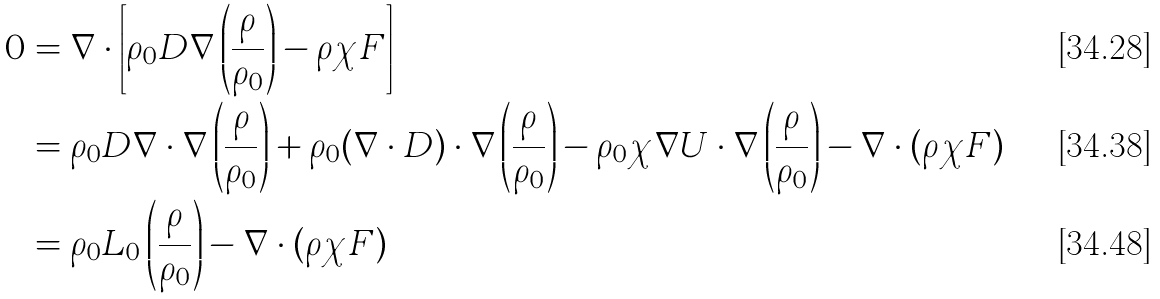Convert formula to latex. <formula><loc_0><loc_0><loc_500><loc_500>0 & = \nabla \cdot \left [ \rho _ { 0 } D \nabla \left ( \frac { \rho } { \rho _ { 0 } } \right ) - \rho \chi F \right ] \\ & = \rho _ { 0 } D \nabla \cdot \nabla \left ( \frac { \rho } { \rho _ { 0 } } \right ) + \rho _ { 0 } ( \nabla \cdot D ) \cdot \nabla \left ( \frac { \rho } { \rho _ { 0 } } \right ) - \rho _ { 0 } \chi \nabla U \cdot \nabla \left ( \frac { \rho } { \rho _ { 0 } } \right ) - \nabla \cdot ( \rho \chi F ) \\ & = \rho _ { 0 } L _ { 0 } \left ( \frac { \rho } { \rho _ { 0 } } \right ) - \nabla \cdot ( \rho \chi F )</formula> 